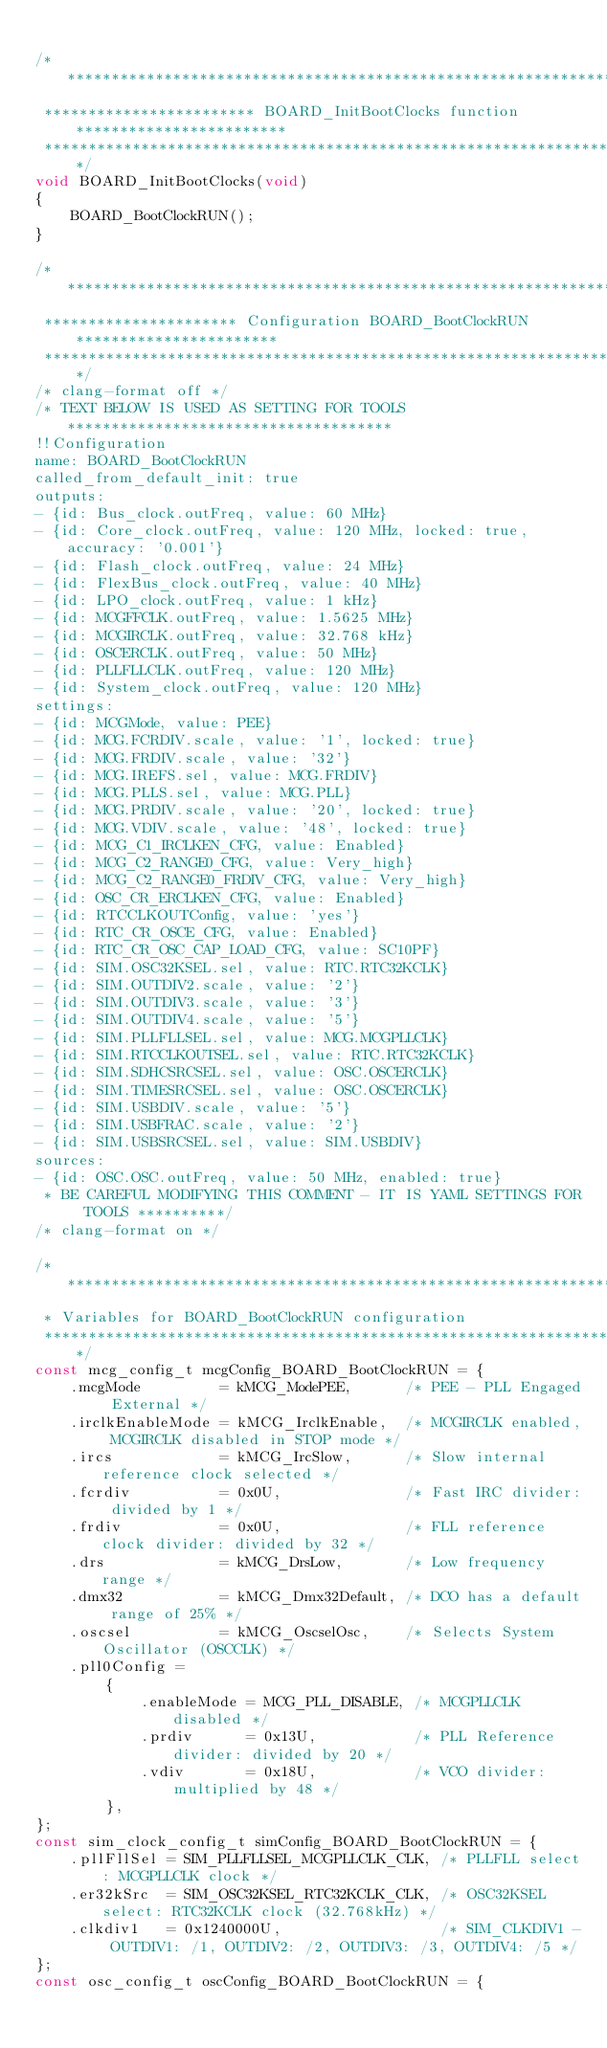Convert code to text. <code><loc_0><loc_0><loc_500><loc_500><_C_>
/*******************************************************************************
 ************************ BOARD_InitBootClocks function ************************
 ******************************************************************************/
void BOARD_InitBootClocks(void)
{
    BOARD_BootClockRUN();
}

/*******************************************************************************
 ********************** Configuration BOARD_BootClockRUN ***********************
 ******************************************************************************/
/* clang-format off */
/* TEXT BELOW IS USED AS SETTING FOR TOOLS *************************************
!!Configuration
name: BOARD_BootClockRUN
called_from_default_init: true
outputs:
- {id: Bus_clock.outFreq, value: 60 MHz}
- {id: Core_clock.outFreq, value: 120 MHz, locked: true, accuracy: '0.001'}
- {id: Flash_clock.outFreq, value: 24 MHz}
- {id: FlexBus_clock.outFreq, value: 40 MHz}
- {id: LPO_clock.outFreq, value: 1 kHz}
- {id: MCGFFCLK.outFreq, value: 1.5625 MHz}
- {id: MCGIRCLK.outFreq, value: 32.768 kHz}
- {id: OSCERCLK.outFreq, value: 50 MHz}
- {id: PLLFLLCLK.outFreq, value: 120 MHz}
- {id: System_clock.outFreq, value: 120 MHz}
settings:
- {id: MCGMode, value: PEE}
- {id: MCG.FCRDIV.scale, value: '1', locked: true}
- {id: MCG.FRDIV.scale, value: '32'}
- {id: MCG.IREFS.sel, value: MCG.FRDIV}
- {id: MCG.PLLS.sel, value: MCG.PLL}
- {id: MCG.PRDIV.scale, value: '20', locked: true}
- {id: MCG.VDIV.scale, value: '48', locked: true}
- {id: MCG_C1_IRCLKEN_CFG, value: Enabled}
- {id: MCG_C2_RANGE0_CFG, value: Very_high}
- {id: MCG_C2_RANGE0_FRDIV_CFG, value: Very_high}
- {id: OSC_CR_ERCLKEN_CFG, value: Enabled}
- {id: RTCCLKOUTConfig, value: 'yes'}
- {id: RTC_CR_OSCE_CFG, value: Enabled}
- {id: RTC_CR_OSC_CAP_LOAD_CFG, value: SC10PF}
- {id: SIM.OSC32KSEL.sel, value: RTC.RTC32KCLK}
- {id: SIM.OUTDIV2.scale, value: '2'}
- {id: SIM.OUTDIV3.scale, value: '3'}
- {id: SIM.OUTDIV4.scale, value: '5'}
- {id: SIM.PLLFLLSEL.sel, value: MCG.MCGPLLCLK}
- {id: SIM.RTCCLKOUTSEL.sel, value: RTC.RTC32KCLK}
- {id: SIM.SDHCSRCSEL.sel, value: OSC.OSCERCLK}
- {id: SIM.TIMESRCSEL.sel, value: OSC.OSCERCLK}
- {id: SIM.USBDIV.scale, value: '5'}
- {id: SIM.USBFRAC.scale, value: '2'}
- {id: SIM.USBSRCSEL.sel, value: SIM.USBDIV}
sources:
- {id: OSC.OSC.outFreq, value: 50 MHz, enabled: true}
 * BE CAREFUL MODIFYING THIS COMMENT - IT IS YAML SETTINGS FOR TOOLS **********/
/* clang-format on */

/*******************************************************************************
 * Variables for BOARD_BootClockRUN configuration
 ******************************************************************************/
const mcg_config_t mcgConfig_BOARD_BootClockRUN = {
    .mcgMode         = kMCG_ModePEE,      /* PEE - PLL Engaged External */
    .irclkEnableMode = kMCG_IrclkEnable,  /* MCGIRCLK enabled, MCGIRCLK disabled in STOP mode */
    .ircs            = kMCG_IrcSlow,      /* Slow internal reference clock selected */
    .fcrdiv          = 0x0U,              /* Fast IRC divider: divided by 1 */
    .frdiv           = 0x0U,              /* FLL reference clock divider: divided by 32 */
    .drs             = kMCG_DrsLow,       /* Low frequency range */
    .dmx32           = kMCG_Dmx32Default, /* DCO has a default range of 25% */
    .oscsel          = kMCG_OscselOsc,    /* Selects System Oscillator (OSCCLK) */
    .pll0Config =
        {
            .enableMode = MCG_PLL_DISABLE, /* MCGPLLCLK disabled */
            .prdiv      = 0x13U,           /* PLL Reference divider: divided by 20 */
            .vdiv       = 0x18U,           /* VCO divider: multiplied by 48 */
        },
};
const sim_clock_config_t simConfig_BOARD_BootClockRUN = {
    .pllFllSel = SIM_PLLFLLSEL_MCGPLLCLK_CLK, /* PLLFLL select: MCGPLLCLK clock */
    .er32kSrc  = SIM_OSC32KSEL_RTC32KCLK_CLK, /* OSC32KSEL select: RTC32KCLK clock (32.768kHz) */
    .clkdiv1   = 0x1240000U,                  /* SIM_CLKDIV1 - OUTDIV1: /1, OUTDIV2: /2, OUTDIV3: /3, OUTDIV4: /5 */
};
const osc_config_t oscConfig_BOARD_BootClockRUN = {</code> 